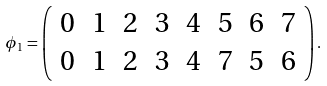Convert formula to latex. <formula><loc_0><loc_0><loc_500><loc_500>\phi _ { 1 } = \left ( \begin{array} { c c c c c c c c c c c c } 0 & 1 & 2 & 3 & 4 & 5 & 6 & 7 \\ 0 & 1 & 2 & 3 & 4 & 7 & 5 & 6 \end{array} \right ) .</formula> 